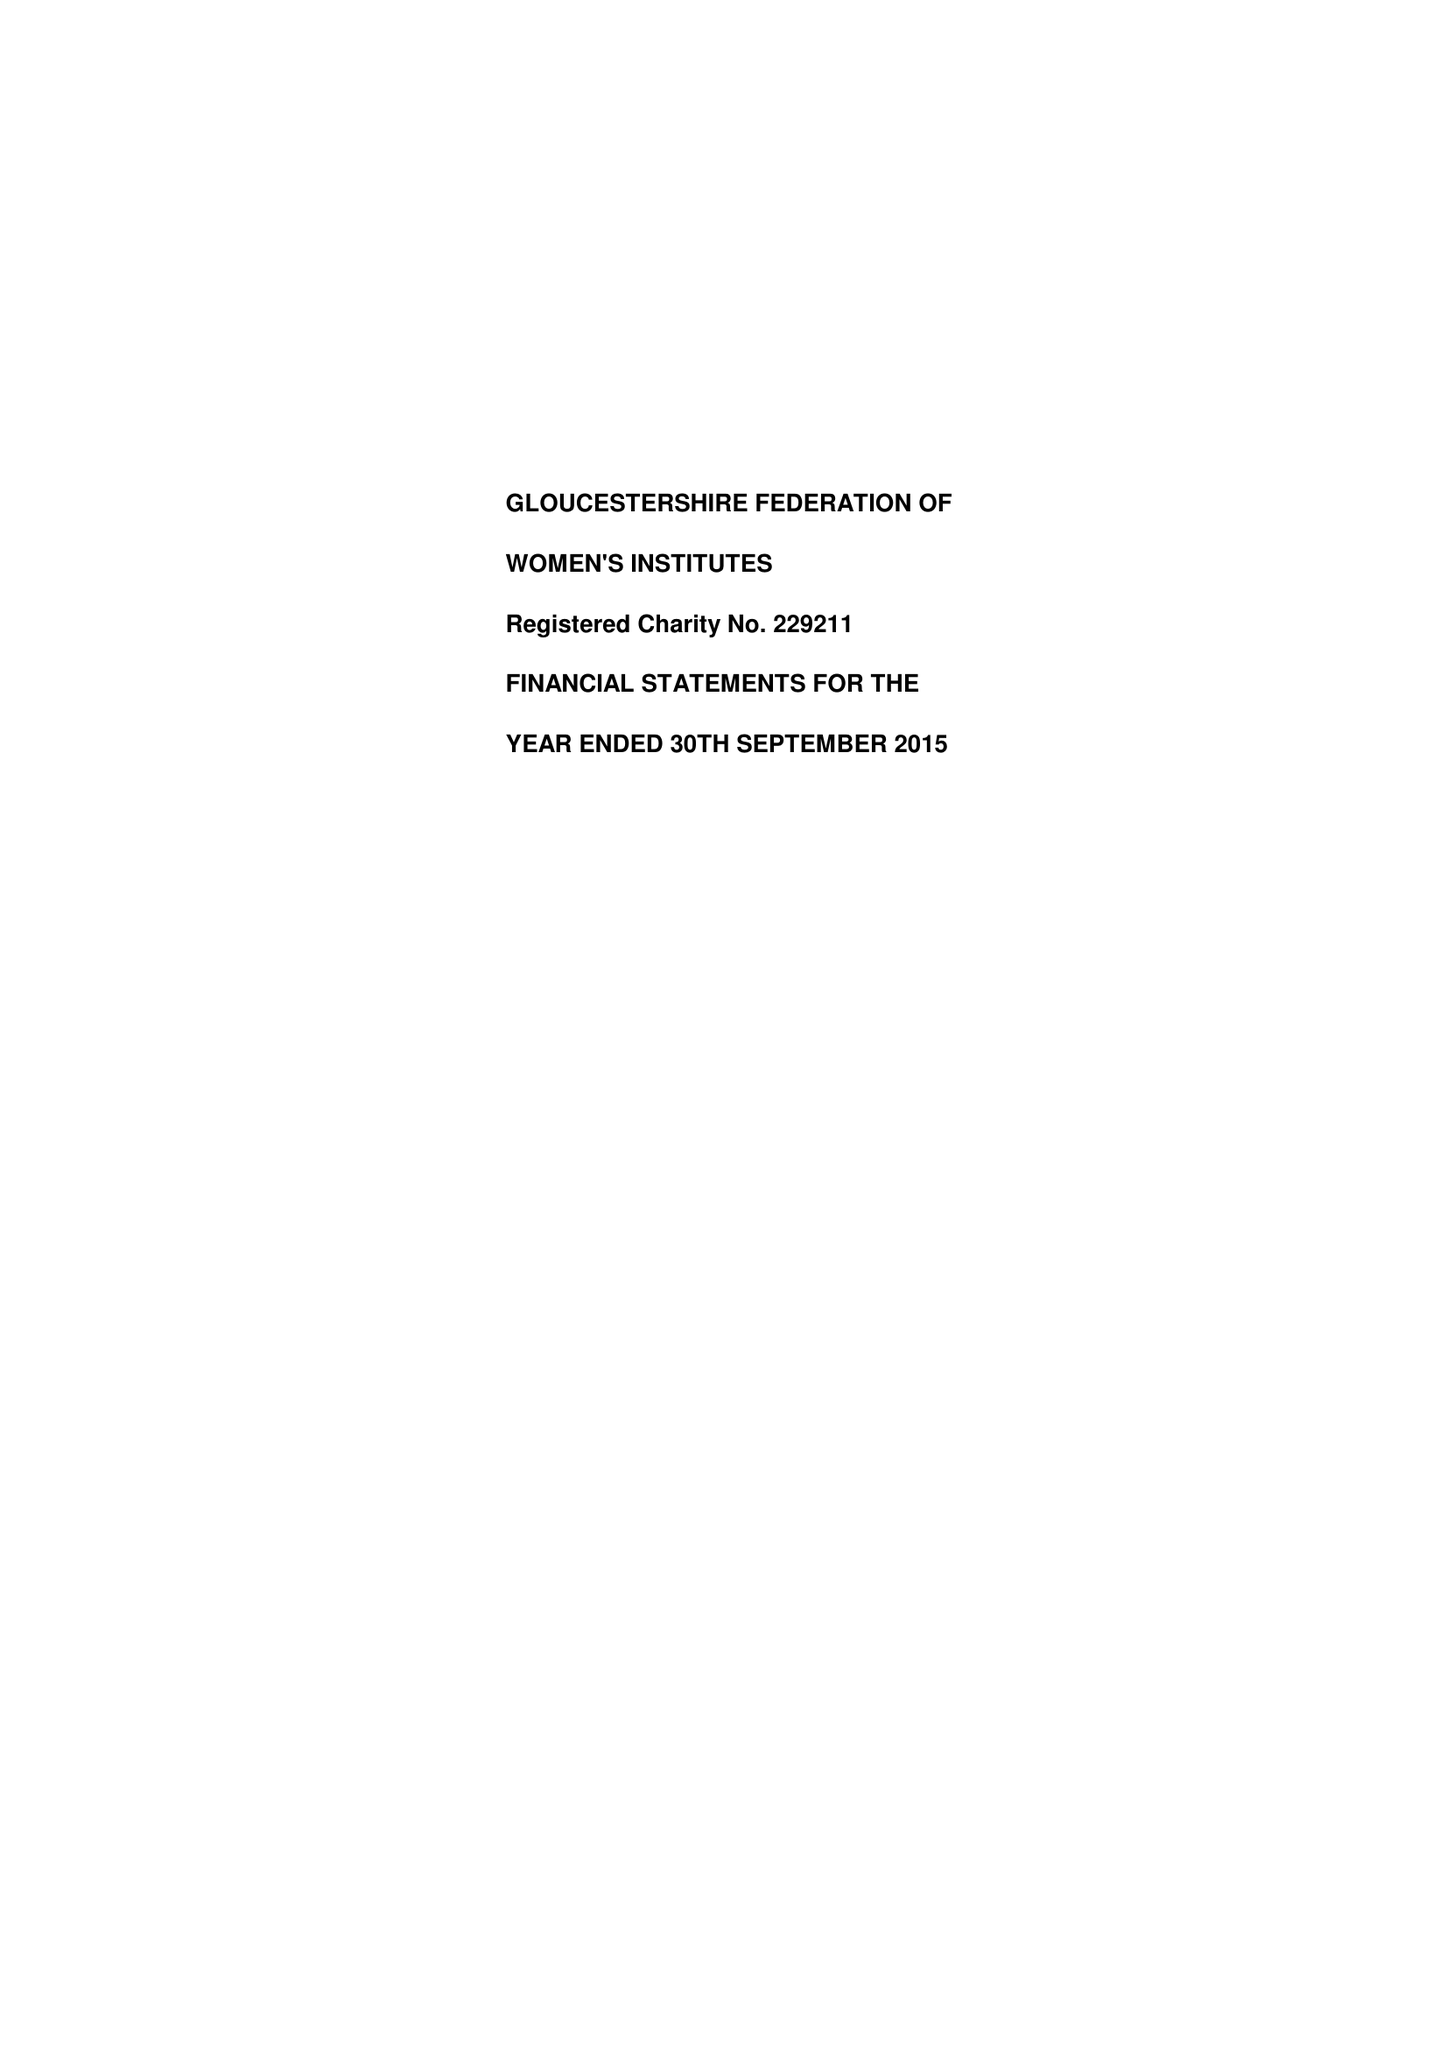What is the value for the address__postcode?
Answer the question using a single word or phrase. GL1 1UL 